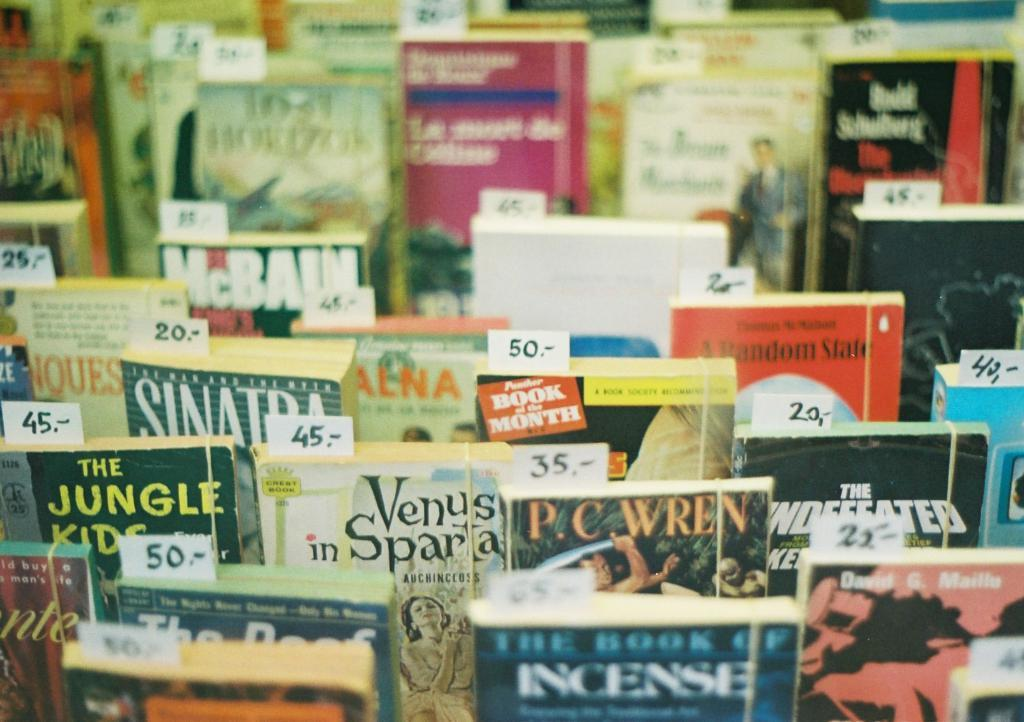<image>
Present a compact description of the photo's key features. Several books are together, including one by P.C. Wren. 